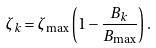Convert formula to latex. <formula><loc_0><loc_0><loc_500><loc_500>\zeta _ { k } = \zeta _ { \max } \left ( 1 - \frac { B _ { k } } { B _ { \max } } \right ) .</formula> 